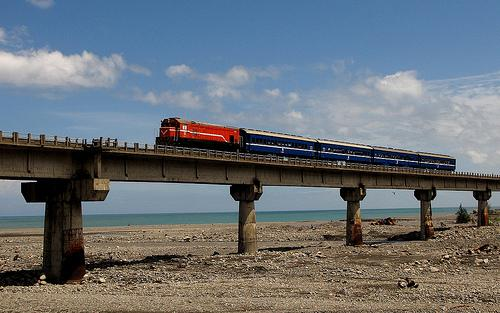Identify the main elements in the foreground and background of the image. In the foreground, there is a train on a bridge with concrete supports, and various train cars. In the background, there is a blue sky with white clouds, a rocky beach, and blue water. Describe the image's overall sentiment or mood. The image has a peaceful and calm mood, with clear weather, a beautiful beach, and a train traveling over a bridge. Give a brief description of the weather and natural setting in the image. The weather appears to be clear with white clouds in a blue sky, and the natural setting includes a rocky beach near blue water and a green tree. What kind of bridge is shown in the image, and what is its purpose? The image shows a concrete bridge with train tracks, and its purpose is to allow the train to travel over the rocky beach and blue water. 